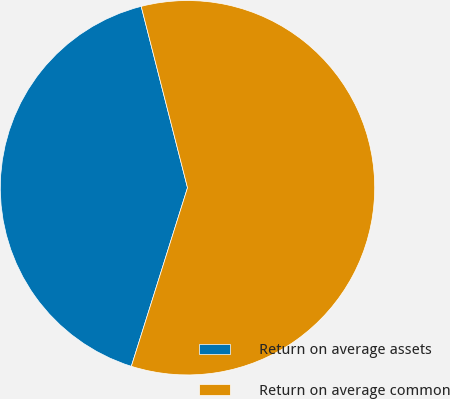<chart> <loc_0><loc_0><loc_500><loc_500><pie_chart><fcel>Return on average assets<fcel>Return on average common<nl><fcel>41.17%<fcel>58.83%<nl></chart> 